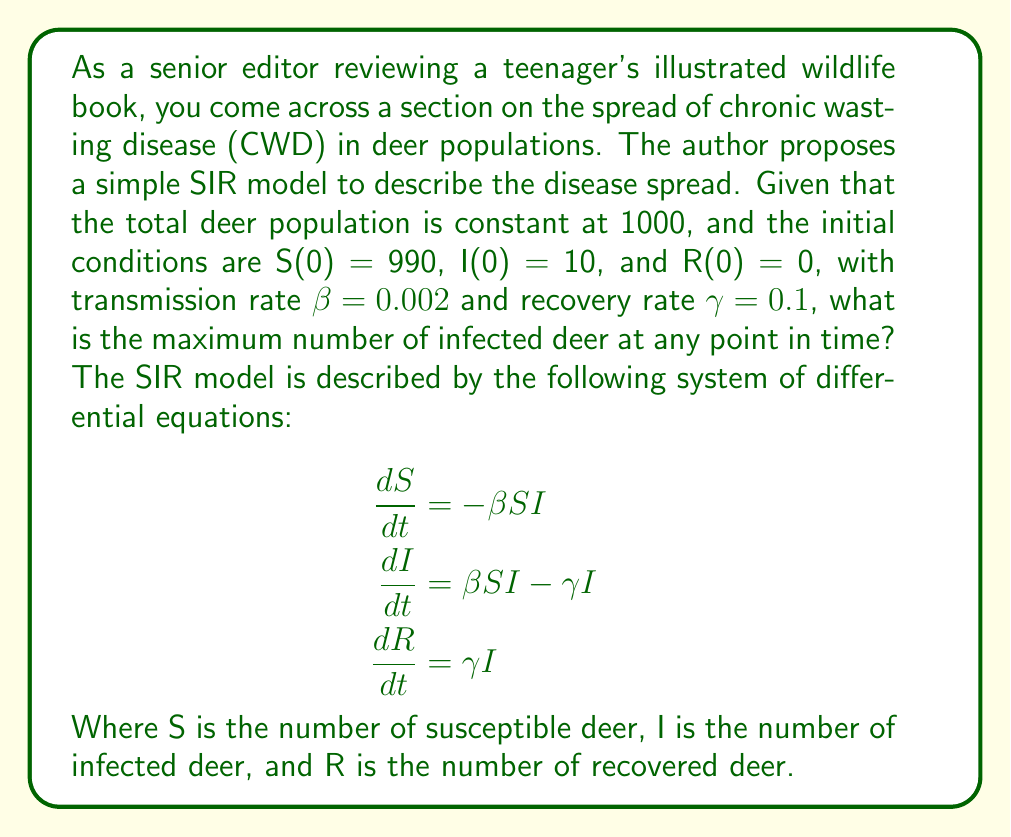Solve this math problem. To solve this problem, we'll follow these steps:

1) First, we need to find the basic reproduction number R₀:
   $$R_0 = \frac{\beta N}{\gamma}$$
   where N is the total population.
   
   $$R_0 = \frac{0.002 \times 1000}{0.1} = 20$$

2) The maximum number of infected occurs when dI/dt = 0:
   $$\beta SI - \gamma I = 0$$
   $$SI = \frac{\gamma}{\beta} = \frac{0.1}{0.002} = 50$$

3) We can use the relation S + I + R = N to eliminate R:
   $$S + I = 1000 - R$$

4) At the peak of infection, we have:
   $$S = \frac{N}{R_0} = \frac{1000}{20} = 50$$

5) Substituting this into the equation from step 3:
   $$50 + I = 1000 - R$$
   $$I = 950 - R$$

6) Now, we can use the relation SI = 50 from step 2:
   $$50 \times (950 - R) = 50$$
   $$47500 - 50R = 50$$
   $$47450 = 50R$$
   $$R = 949$$

7) Finally, we can calculate I:
   $$I = 950 - 949 = 1$$

Therefore, the maximum number of infected deer is 1.
Answer: 1 deer 